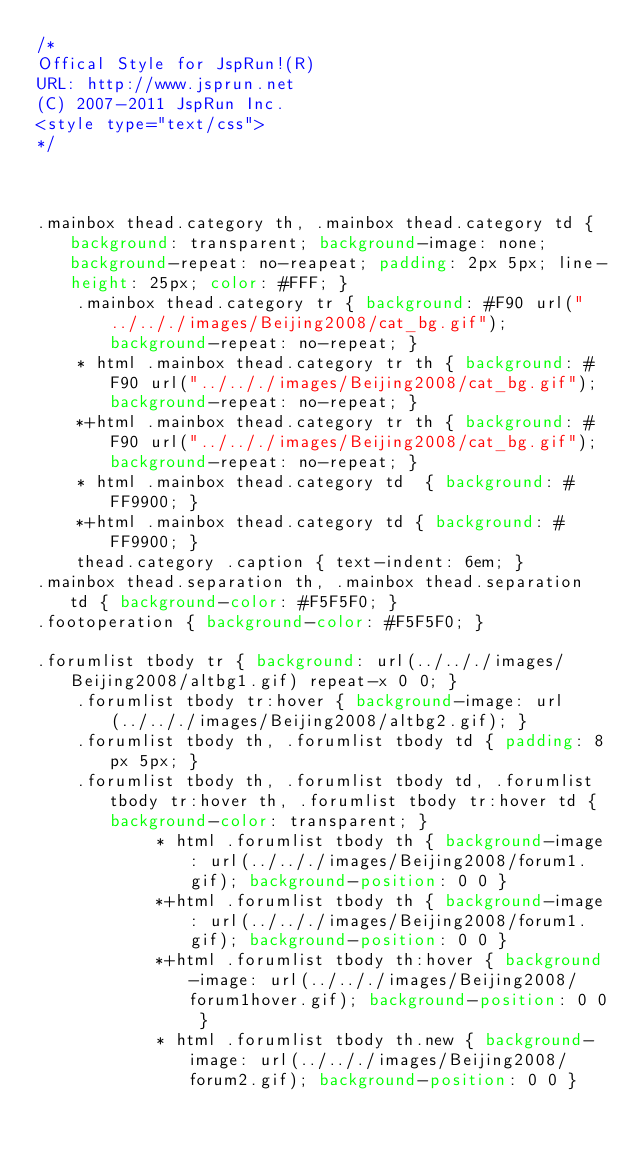<code> <loc_0><loc_0><loc_500><loc_500><_CSS_>/*
Offical Style for JspRun!(R)
URL: http://www.jsprun.net
(C) 2007-2011 JspRun Inc.
<style type="text/css">
*/



.mainbox thead.category th, .mainbox thead.category td { background: transparent; background-image: none; background-repeat: no-reapeat; padding: 2px 5px; line-height: 25px; color: #FFF; }
	.mainbox thead.category tr { background: #F90 url("../.././images/Beijing2008/cat_bg.gif"); background-repeat: no-repeat; }
	* html .mainbox thead.category tr th { background: #F90 url("../.././images/Beijing2008/cat_bg.gif"); background-repeat: no-repeat; }
	*+html .mainbox thead.category tr th { background: #F90 url("../.././images/Beijing2008/cat_bg.gif"); background-repeat: no-repeat; }
	* html .mainbox thead.category td  { background: #FF9900; }
	*+html .mainbox thead.category td { background: #FF9900; }
	thead.category .caption { text-indent: 6em; }
.mainbox thead.separation th, .mainbox thead.separation td { background-color: #F5F5F0; }
.footoperation { background-color: #F5F5F0; }

.forumlist tbody tr { background: url(../.././images/Beijing2008/altbg1.gif) repeat-x 0 0; }
	.forumlist tbody tr:hover { background-image: url(../.././images/Beijing2008/altbg2.gif); }
	.forumlist tbody th, .forumlist tbody td { padding: 8px 5px; }
	.forumlist tbody th, .forumlist tbody td, .forumlist tbody tr:hover th, .forumlist tbody tr:hover td { background-color: transparent; }
			* html .forumlist tbody th { background-image: url(../.././images/Beijing2008/forum1.gif); background-position: 0 0 }
			*+html .forumlist tbody th { background-image: url(../.././images/Beijing2008/forum1.gif); background-position: 0 0 }
			*+html .forumlist tbody th:hover { background-image: url(../.././images/Beijing2008/forum1hover.gif); background-position: 0 0 }
			* html .forumlist tbody th.new { background-image: url(../.././images/Beijing2008/forum2.gif); background-position: 0 0 }</code> 